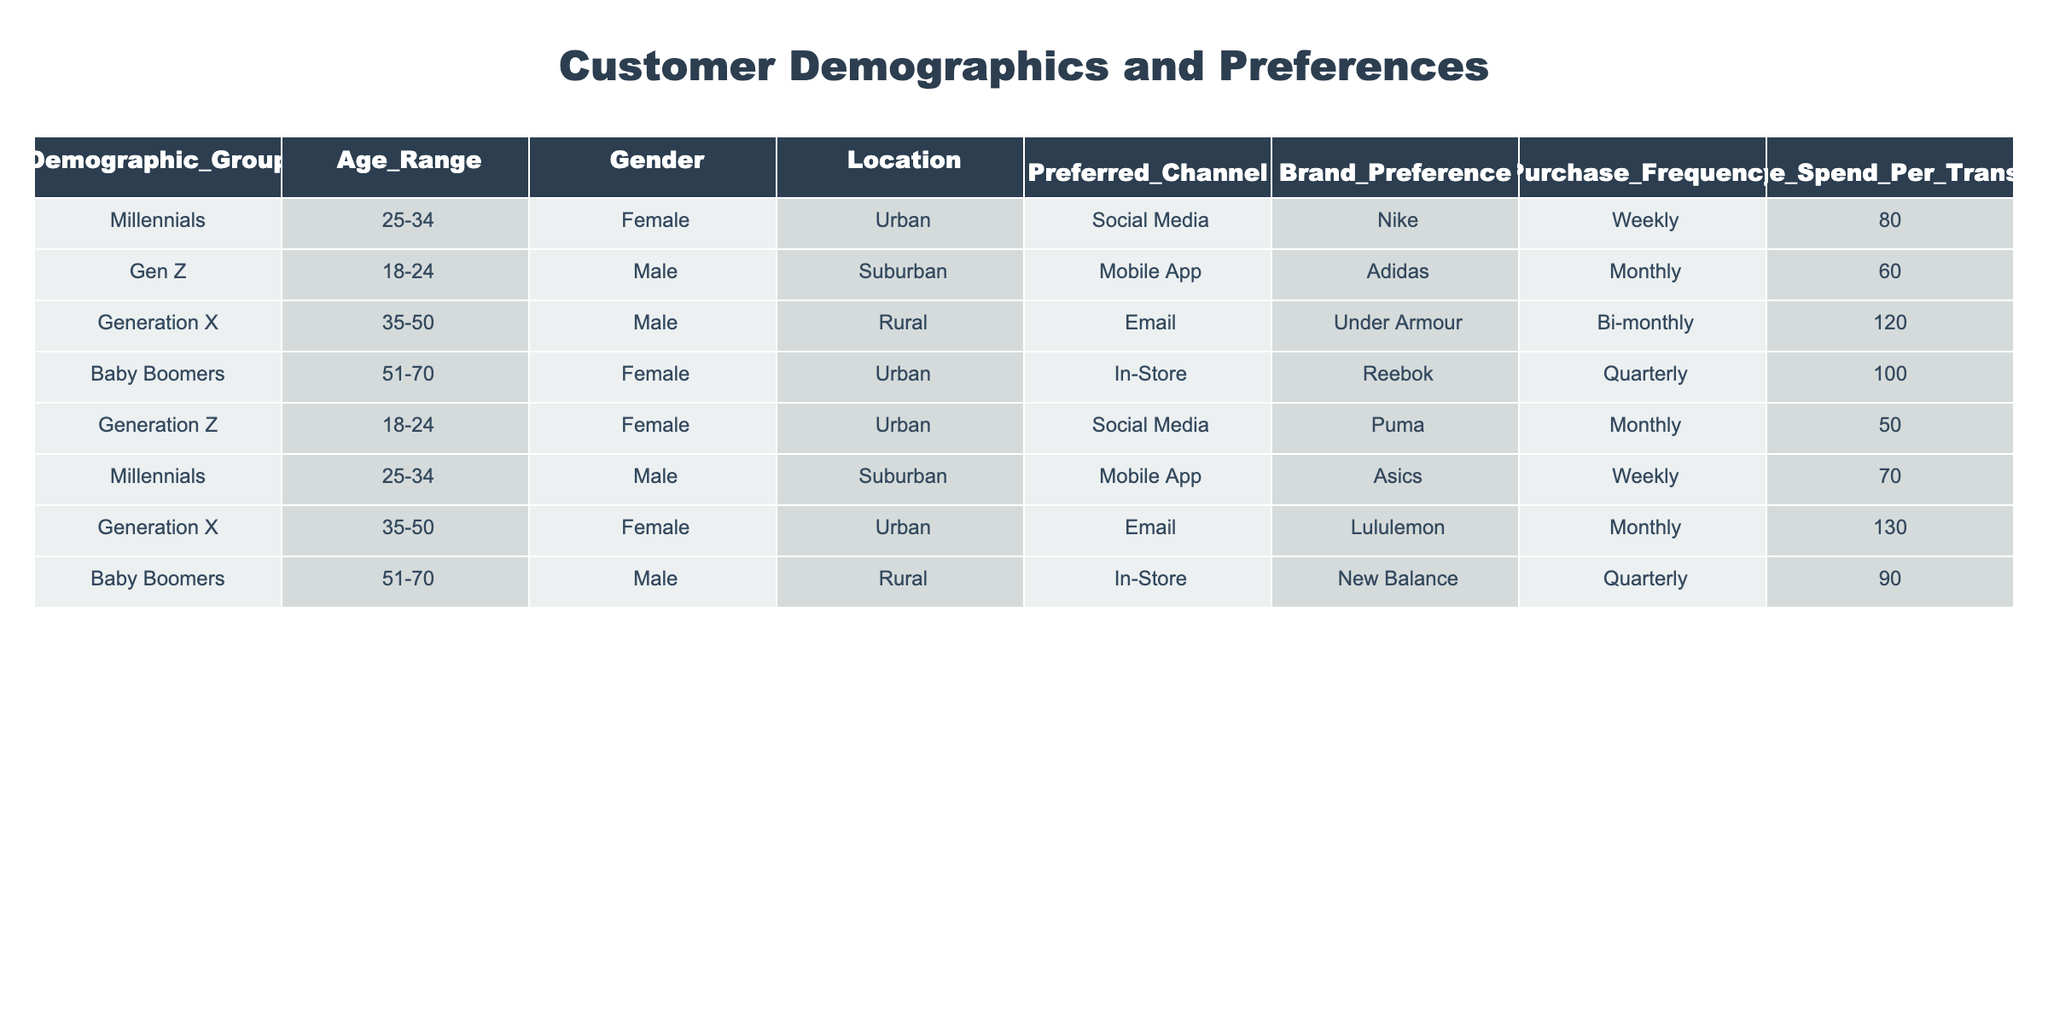What is the preferred channel for Generation Z? Referring to the table, Generation Z has two entries: one for males and one for females. Both entries list "Social Media" as their preferred channel.
Answer: Social Media How often do Millennials purchase? The table shows two groups for Millennials: one female and one male. Both have a purchase frequency of "Weekly."
Answer: Weekly What is the average spend per transaction for Baby Boomers? There are two entries for Baby Boomers in the table, one male and one female, with spending of 100 and 90 respectively. To find the average, we add 100 + 90 = 190, and then divide by 2, giving us 190 / 2 = 95.
Answer: 95 Is the preferred channel for Generation X email? There are two entries for Generation X: one male and one female. Both of them list "Email" as their preferred channel.
Answer: Yes Which demographic group has the highest average spend per transaction? Examining the table, the highest average spend per transaction occurs for Generation X (female) at 130, followed by Generation X (male) at 120, and so forth. The highest value is 130 for Generation X (female).
Answer: Generation X (Female) 